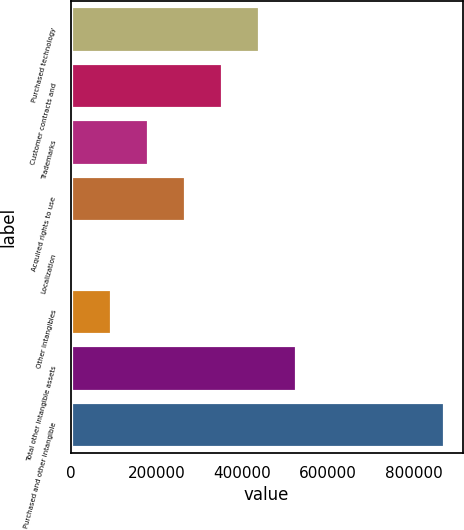Convert chart. <chart><loc_0><loc_0><loc_500><loc_500><bar_chart><fcel>Purchased technology<fcel>Customer contracts and<fcel>Trademarks<fcel>Acquired rights to use<fcel>Localization<fcel>Other intangibles<fcel>Total other intangible assets<fcel>Purchased and other intangible<nl><fcel>439105<fcel>353001<fcel>180794<fcel>266897<fcel>8586<fcel>94689.8<fcel>525209<fcel>869624<nl></chart> 